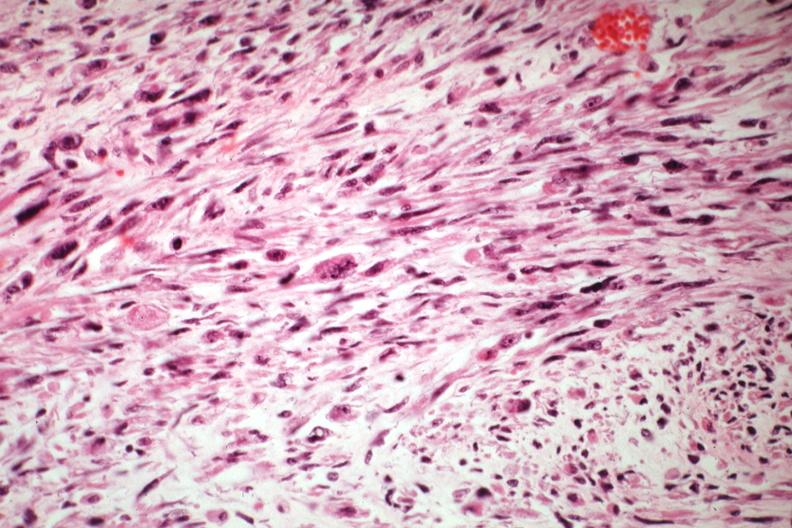what does this image show?
Answer the question using a single word or phrase. Bizarre strap and fusiform cells 